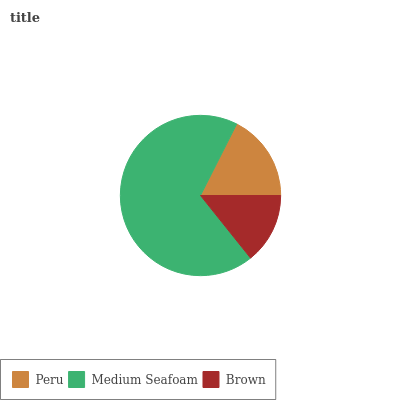Is Brown the minimum?
Answer yes or no. Yes. Is Medium Seafoam the maximum?
Answer yes or no. Yes. Is Medium Seafoam the minimum?
Answer yes or no. No. Is Brown the maximum?
Answer yes or no. No. Is Medium Seafoam greater than Brown?
Answer yes or no. Yes. Is Brown less than Medium Seafoam?
Answer yes or no. Yes. Is Brown greater than Medium Seafoam?
Answer yes or no. No. Is Medium Seafoam less than Brown?
Answer yes or no. No. Is Peru the high median?
Answer yes or no. Yes. Is Peru the low median?
Answer yes or no. Yes. Is Medium Seafoam the high median?
Answer yes or no. No. Is Brown the low median?
Answer yes or no. No. 